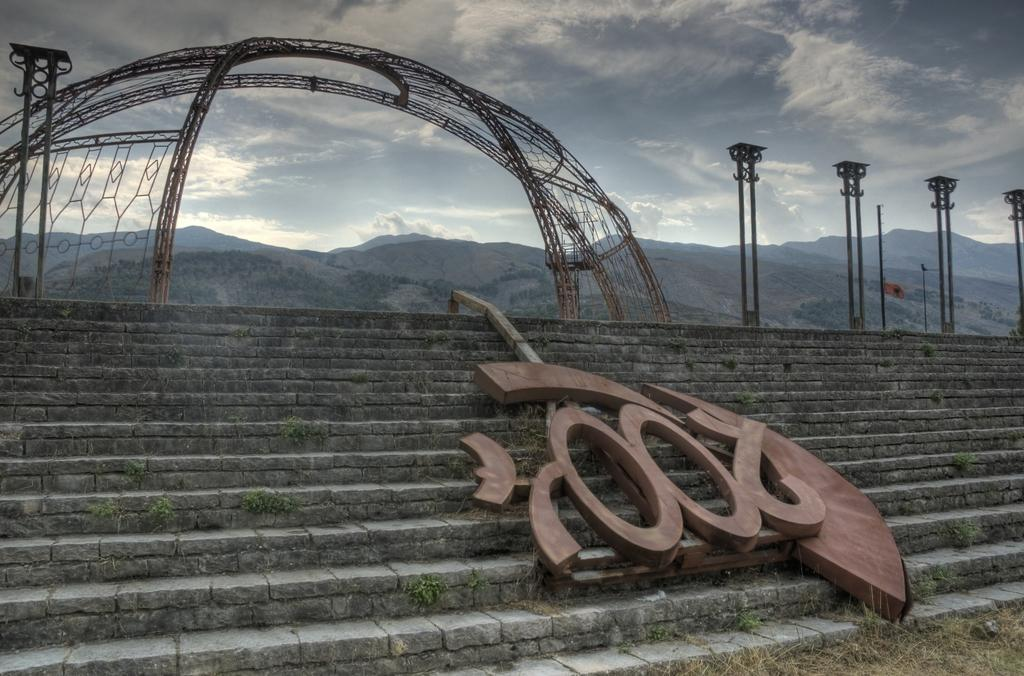What type of architectural feature is present in the image? There are steps in the image. What is the board used for in the image? The board's purpose is not clear from the image. What type of structure is depicted in the image? There is an arch in the image. What type of support structures are present in the image? There are poles in the image. What type of natural landscape is visible in the image? There are mountains in the image. What is the weather like in the image? The sky is cloudy in the image. Can you tell me how many ants are crawling on the board in the image? There are no ants visible on the board in the image. What type of road can be seen leading up to the arch in the image? There is no road present in the image. 